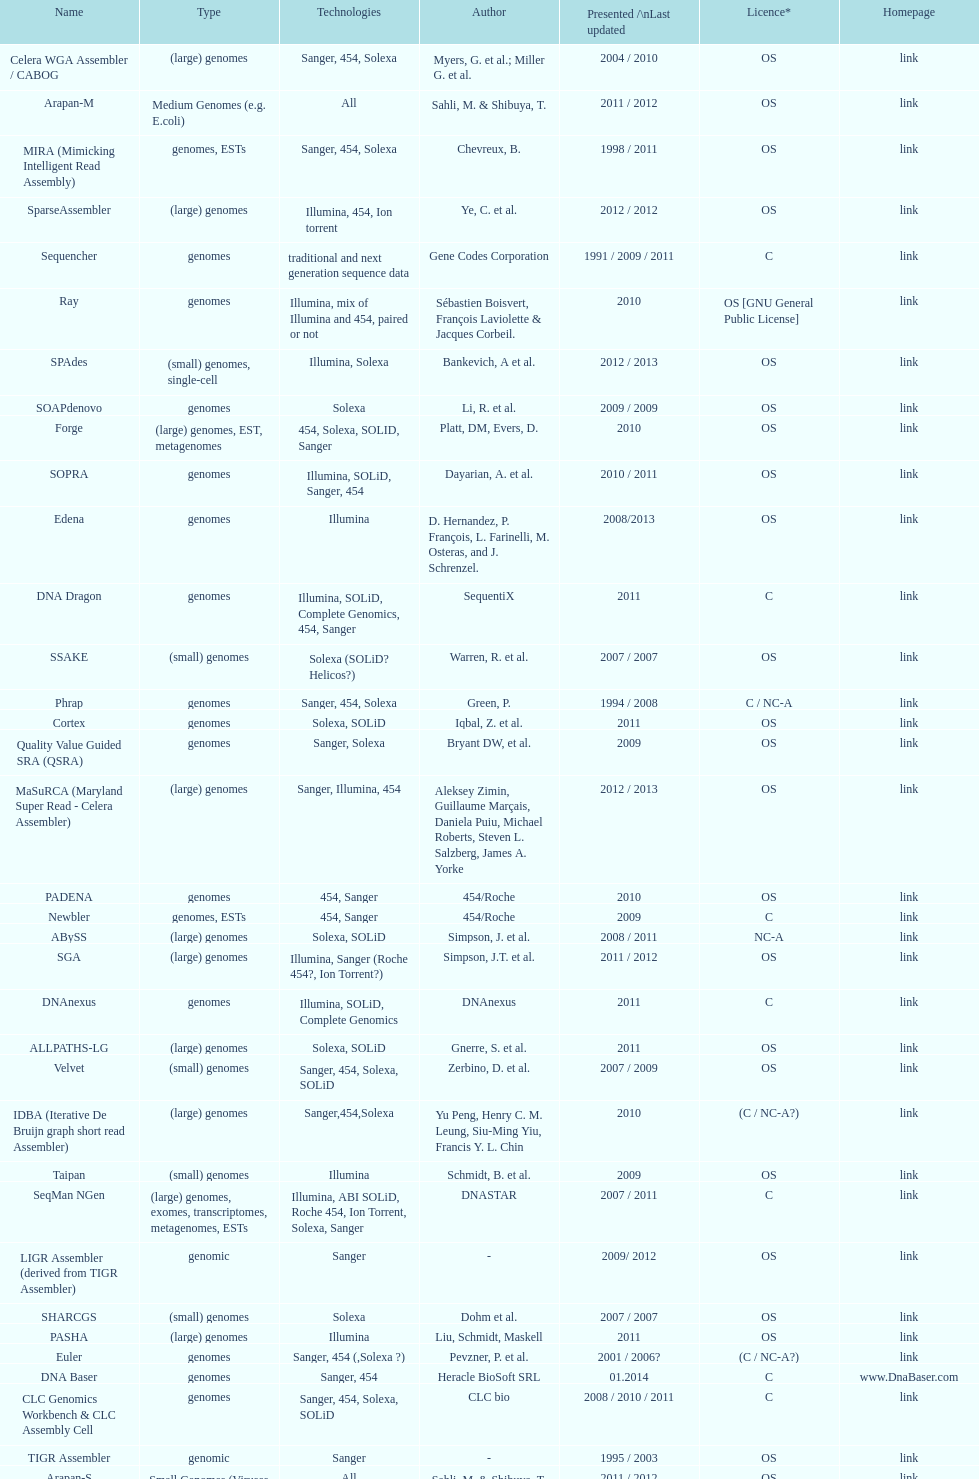When was the velvet last updated? 2009. 